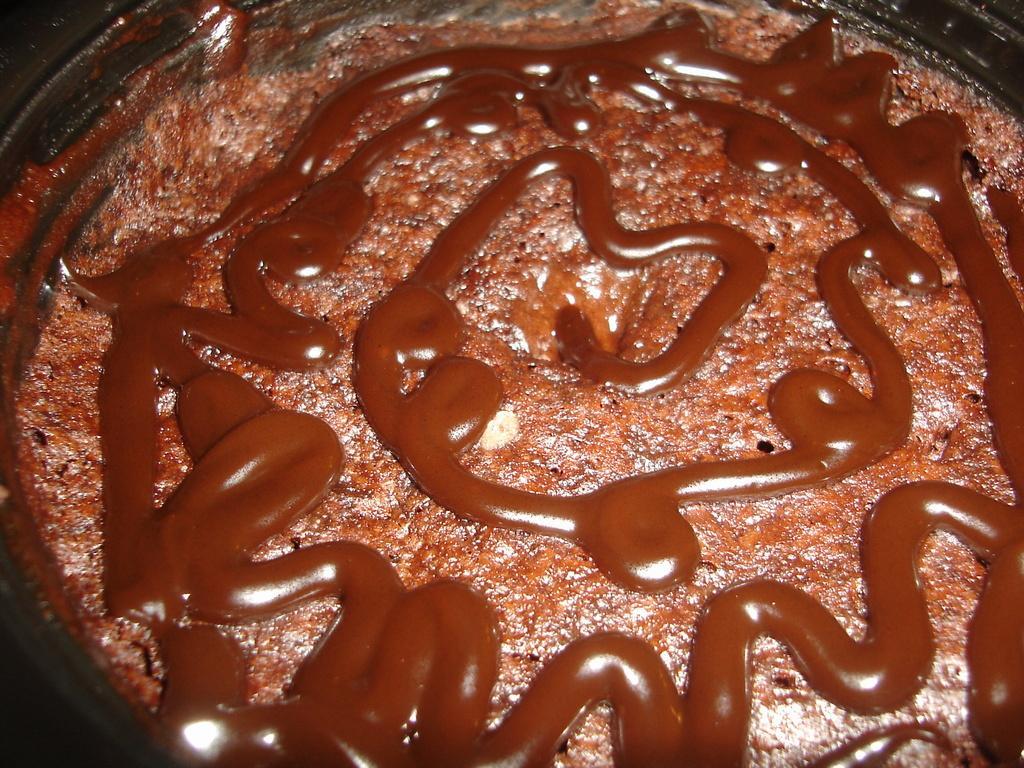In one or two sentences, can you explain what this image depicts? In this picture I can see a food item on the plate. 